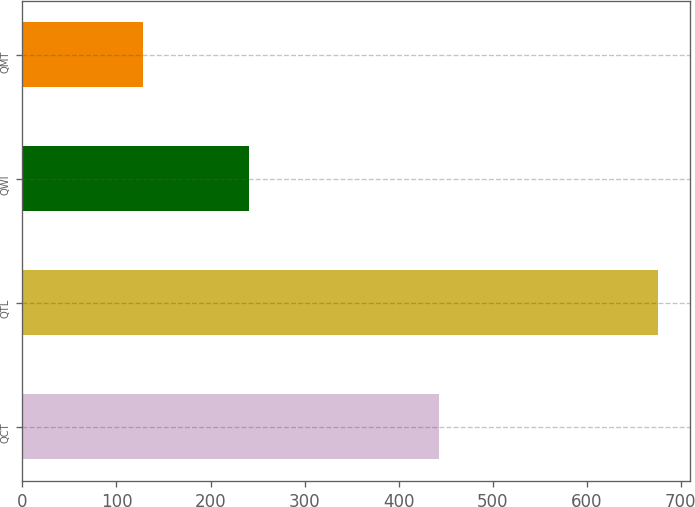<chart> <loc_0><loc_0><loc_500><loc_500><bar_chart><fcel>QCT<fcel>QTL<fcel>QWI<fcel>QMT<nl><fcel>443<fcel>676<fcel>241<fcel>128<nl></chart> 